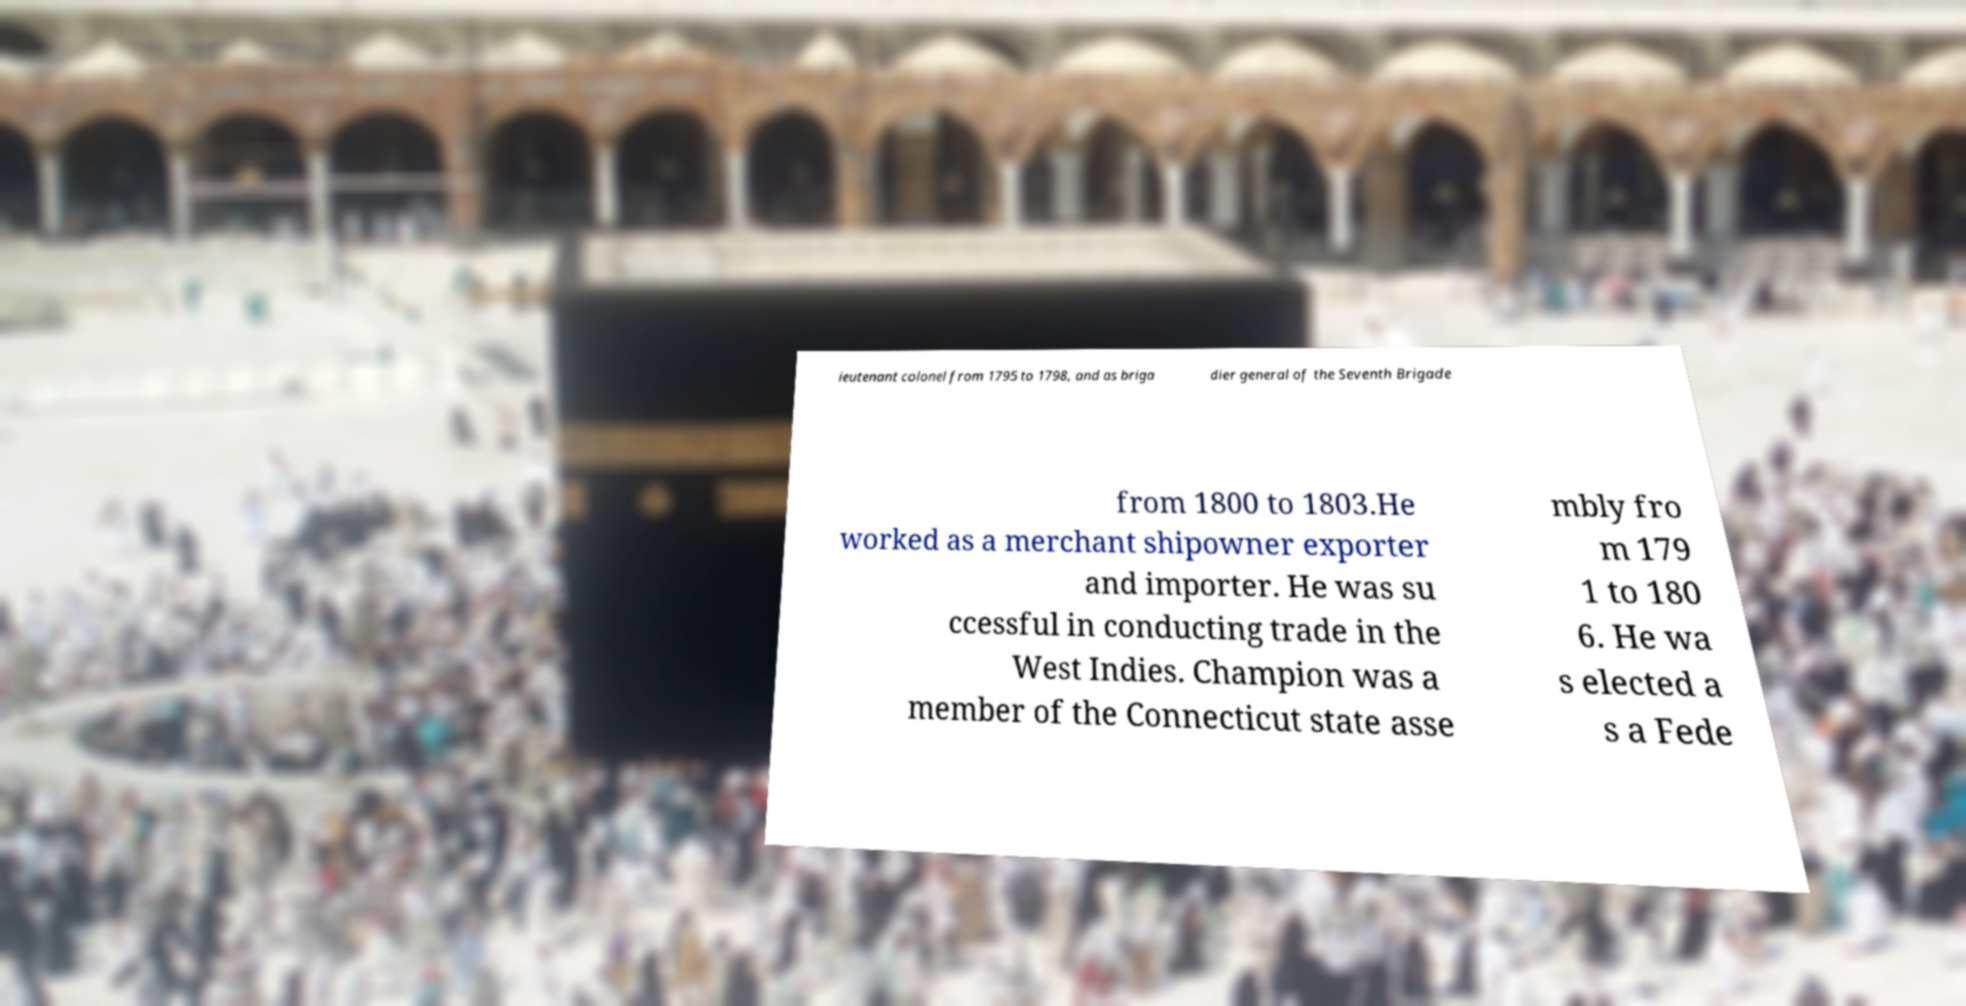Could you extract and type out the text from this image? ieutenant colonel from 1795 to 1798, and as briga dier general of the Seventh Brigade from 1800 to 1803.He worked as a merchant shipowner exporter and importer. He was su ccessful in conducting trade in the West Indies. Champion was a member of the Connecticut state asse mbly fro m 179 1 to 180 6. He wa s elected a s a Fede 